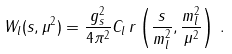Convert formula to latex. <formula><loc_0><loc_0><loc_500><loc_500>W _ { l } ( s , \mu ^ { 2 } ) = \frac { g _ { s } ^ { 2 } } { 4 \pi ^ { 2 } } C _ { l } \, r \left ( \frac { s } { m _ { l } ^ { 2 } } , \frac { m _ { l } ^ { 2 } } { \mu ^ { 2 } } \right ) \, .</formula> 